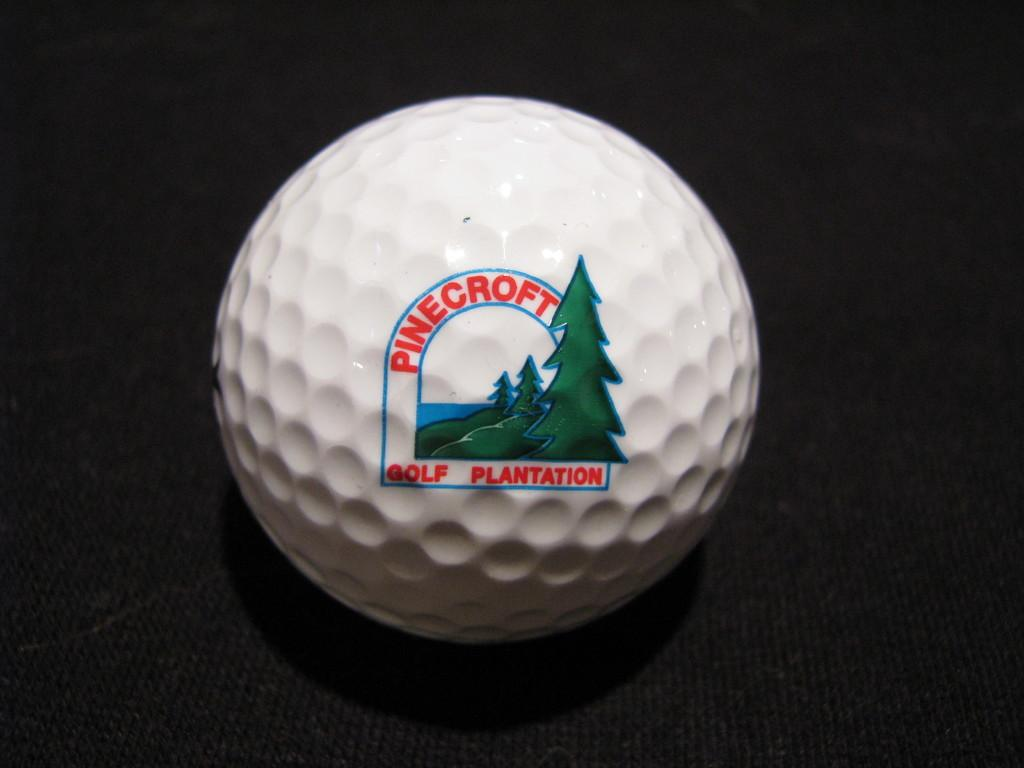<image>
Render a clear and concise summary of the photo. A golf ball with Pinecroft printed on it. 